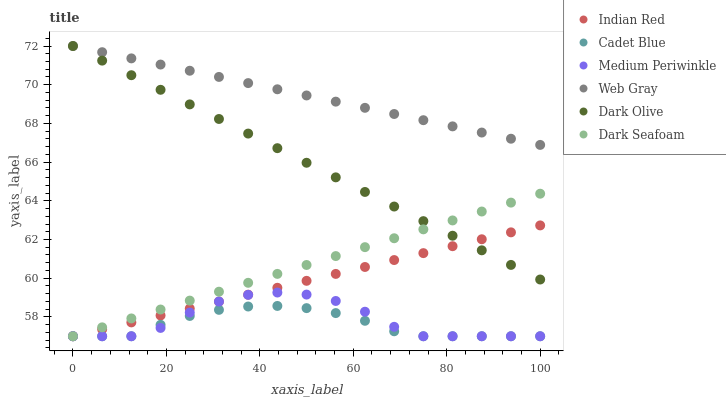Does Cadet Blue have the minimum area under the curve?
Answer yes or no. Yes. Does Web Gray have the maximum area under the curve?
Answer yes or no. Yes. Does Dark Olive have the minimum area under the curve?
Answer yes or no. No. Does Dark Olive have the maximum area under the curve?
Answer yes or no. No. Is Web Gray the smoothest?
Answer yes or no. Yes. Is Medium Periwinkle the roughest?
Answer yes or no. Yes. Is Dark Olive the smoothest?
Answer yes or no. No. Is Dark Olive the roughest?
Answer yes or no. No. Does Medium Periwinkle have the lowest value?
Answer yes or no. Yes. Does Dark Olive have the lowest value?
Answer yes or no. No. Does Dark Olive have the highest value?
Answer yes or no. Yes. Does Medium Periwinkle have the highest value?
Answer yes or no. No. Is Cadet Blue less than Dark Olive?
Answer yes or no. Yes. Is Web Gray greater than Cadet Blue?
Answer yes or no. Yes. Does Indian Red intersect Cadet Blue?
Answer yes or no. Yes. Is Indian Red less than Cadet Blue?
Answer yes or no. No. Is Indian Red greater than Cadet Blue?
Answer yes or no. No. Does Cadet Blue intersect Dark Olive?
Answer yes or no. No. 